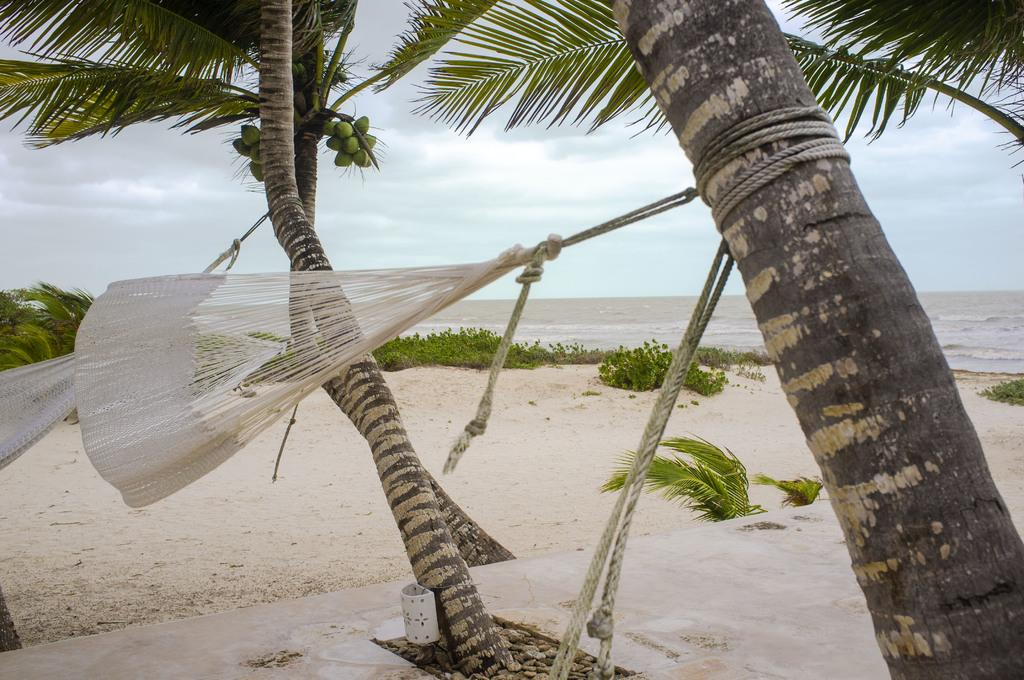What type of recreational equipment can be seen in the image? There are two swings tied to the trees in the image. What is hanging from the trees? The trees have coconuts. What type of vegetation is present on the land? There are plants on the land. What can be seen in the middle of the image? There is water visible in the middle of the image. What is visible at the top of the image? The sky is visible at the top of the image. What type of jelly can be seen floating in the water in the image? There is no jelly present in the image; it features swings, trees, plants, water, and sky. What holiday is being celebrated in the image? There is no indication of a holiday being celebrated in the image. 